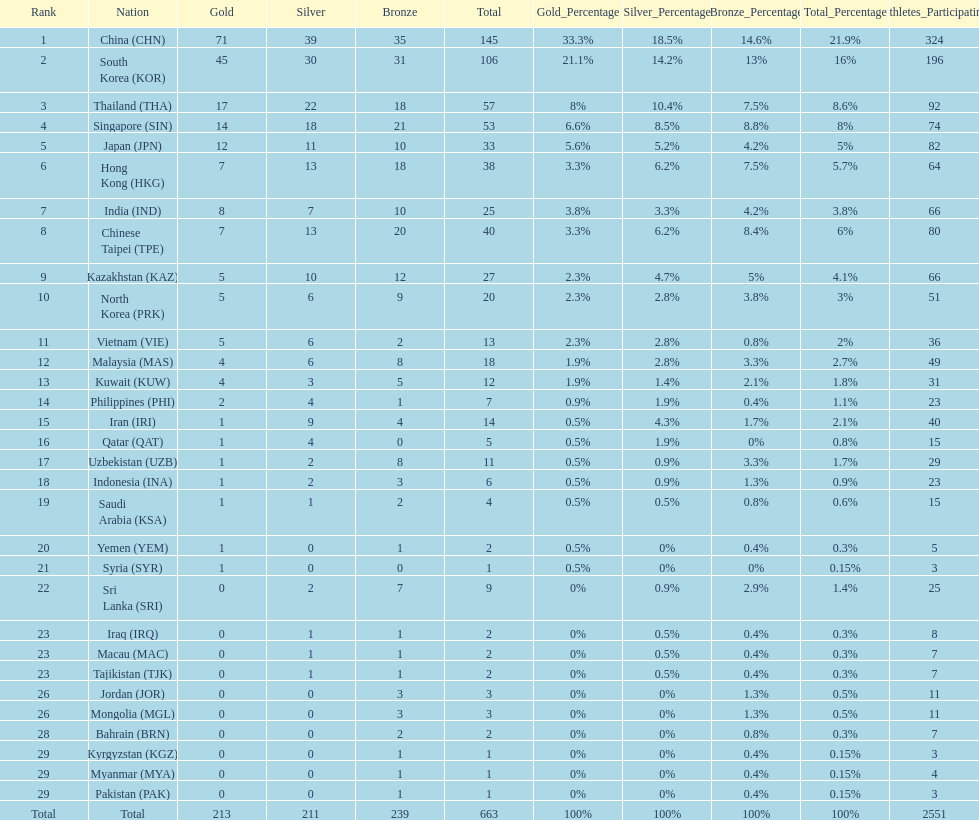Can you give me this table as a dict? {'header': ['Rank', 'Nation', 'Gold', 'Silver', 'Bronze', 'Total', 'Gold_Percentage', 'Silver_Percentage', 'Bronze_Percentage', 'Total_Percentage', 'Athletes_Participating'], 'rows': [['1', 'China\xa0(CHN)', '71', '39', '35', '145', '33.3%', '18.5%', '14.6%', '21.9%', '324'], ['2', 'South Korea\xa0(KOR)', '45', '30', '31', '106', '21.1%', '14.2%', '13%', '16%', '196'], ['3', 'Thailand\xa0(THA)', '17', '22', '18', '57', '8%', '10.4%', '7.5%', '8.6%', '92'], ['4', 'Singapore\xa0(SIN)', '14', '18', '21', '53', '6.6%', '8.5%', '8.8%', '8%', '74'], ['5', 'Japan\xa0(JPN)', '12', '11', '10', '33', '5.6%', '5.2%', '4.2%', '5%', '82'], ['6', 'Hong Kong\xa0(HKG)', '7', '13', '18', '38', '3.3%', '6.2%', '7.5%', '5.7%', '64'], ['7', 'India\xa0(IND)', '8', '7', '10', '25', '3.8%', '3.3%', '4.2%', '3.8%', '66'], ['8', 'Chinese Taipei\xa0(TPE)', '7', '13', '20', '40', '3.3%', '6.2%', '8.4%', '6%', '80'], ['9', 'Kazakhstan\xa0(KAZ)', '5', '10', '12', '27', '2.3%', '4.7%', '5%', '4.1%', '66'], ['10', 'North Korea\xa0(PRK)', '5', '6', '9', '20', '2.3%', '2.8%', '3.8%', '3%', '51'], ['11', 'Vietnam\xa0(VIE)', '5', '6', '2', '13', '2.3%', '2.8%', '0.8%', '2%', '36'], ['12', 'Malaysia\xa0(MAS)', '4', '6', '8', '18', '1.9%', '2.8%', '3.3%', '2.7%', '49'], ['13', 'Kuwait\xa0(KUW)', '4', '3', '5', '12', '1.9%', '1.4%', '2.1%', '1.8%', '31'], ['14', 'Philippines\xa0(PHI)', '2', '4', '1', '7', '0.9%', '1.9%', '0.4%', '1.1%', '23'], ['15', 'Iran\xa0(IRI)', '1', '9', '4', '14', '0.5%', '4.3%', '1.7%', '2.1%', '40'], ['16', 'Qatar\xa0(QAT)', '1', '4', '0', '5', '0.5%', '1.9%', '0%', '0.8%', '15'], ['17', 'Uzbekistan\xa0(UZB)', '1', '2', '8', '11', '0.5%', '0.9%', '3.3%', '1.7%', '29'], ['18', 'Indonesia\xa0(INA)', '1', '2', '3', '6', '0.5%', '0.9%', '1.3%', '0.9%', '23'], ['19', 'Saudi Arabia\xa0(KSA)', '1', '1', '2', '4', '0.5%', '0.5%', '0.8%', '0.6%', '15'], ['20', 'Yemen\xa0(YEM)', '1', '0', '1', '2', '0.5%', '0%', '0.4%', '0.3%', '5'], ['21', 'Syria\xa0(SYR)', '1', '0', '0', '1', '0.5%', '0%', '0%', '0.15%', '3'], ['22', 'Sri Lanka\xa0(SRI)', '0', '2', '7', '9', '0%', '0.9%', '2.9%', '1.4%', '25'], ['23', 'Iraq\xa0(IRQ)', '0', '1', '1', '2', '0%', '0.5%', '0.4%', '0.3%', '8'], ['23', 'Macau\xa0(MAC)', '0', '1', '1', '2', '0%', '0.5%', '0.4%', '0.3%', '7'], ['23', 'Tajikistan\xa0(TJK)', '0', '1', '1', '2', '0%', '0.5%', '0.4%', '0.3%', '7'], ['26', 'Jordan\xa0(JOR)', '0', '0', '3', '3', '0%', '0%', '1.3%', '0.5%', '11'], ['26', 'Mongolia\xa0(MGL)', '0', '0', '3', '3', '0%', '0%', '1.3%', '0.5%', '11'], ['28', 'Bahrain\xa0(BRN)', '0', '0', '2', '2', '0%', '0%', '0.8%', '0.3%', '7'], ['29', 'Kyrgyzstan\xa0(KGZ)', '0', '0', '1', '1', '0%', '0%', '0.4%', '0.15%', '3'], ['29', 'Myanmar\xa0(MYA)', '0', '0', '1', '1', '0%', '0%', '0.4%', '0.15%', '4'], ['29', 'Pakistan\xa0(PAK)', '0', '0', '1', '1', '0%', '0%', '0.4%', '0.15%', '3'], ['Total', 'Total', '213', '211', '239', '663', '100%', '100%', '100%', '100%', '2551']]} How many more gold medals must qatar win before they can earn 12 gold medals? 11. 